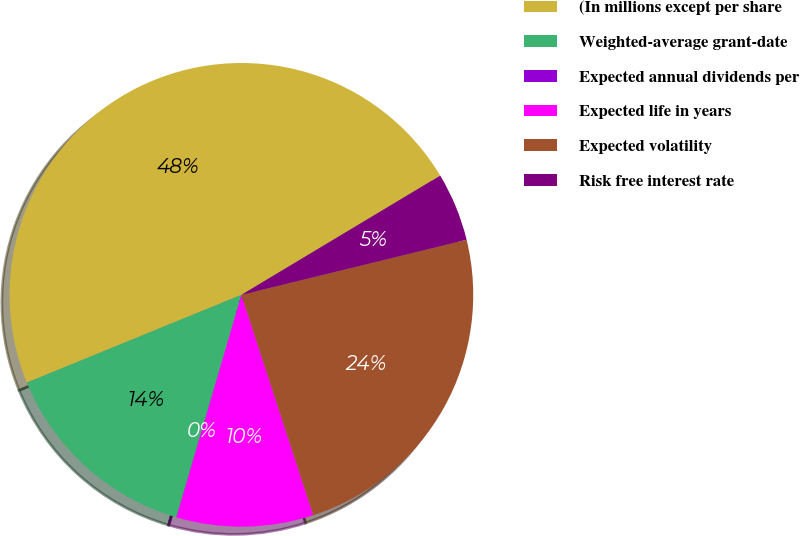<chart> <loc_0><loc_0><loc_500><loc_500><pie_chart><fcel>(In millions except per share<fcel>Weighted-average grant-date<fcel>Expected annual dividends per<fcel>Expected life in years<fcel>Expected volatility<fcel>Risk free interest rate<nl><fcel>47.58%<fcel>14.29%<fcel>0.02%<fcel>9.53%<fcel>23.8%<fcel>4.78%<nl></chart> 